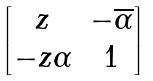Convert formula to latex. <formula><loc_0><loc_0><loc_500><loc_500>\begin{bmatrix} z & - \overline { \alpha } \\ - z \alpha & 1 \end{bmatrix}</formula> 